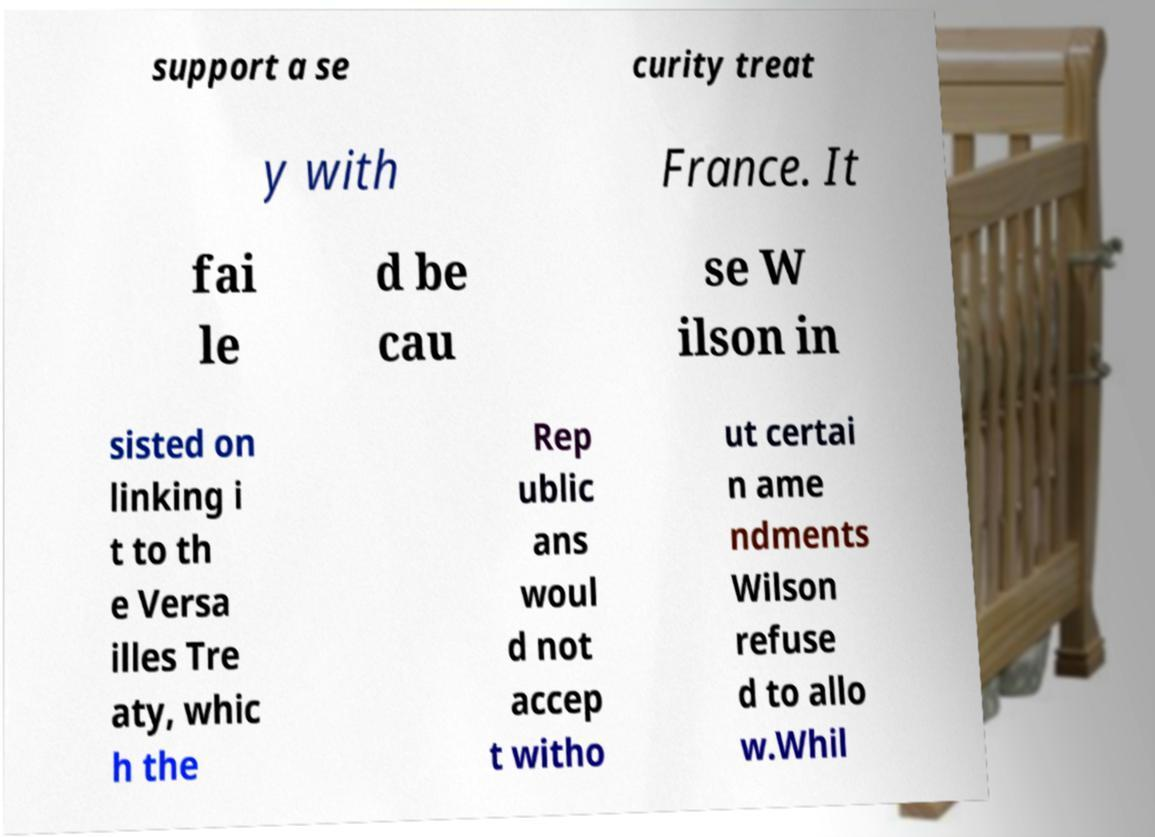Please identify and transcribe the text found in this image. support a se curity treat y with France. It fai le d be cau se W ilson in sisted on linking i t to th e Versa illes Tre aty, whic h the Rep ublic ans woul d not accep t witho ut certai n ame ndments Wilson refuse d to allo w.Whil 